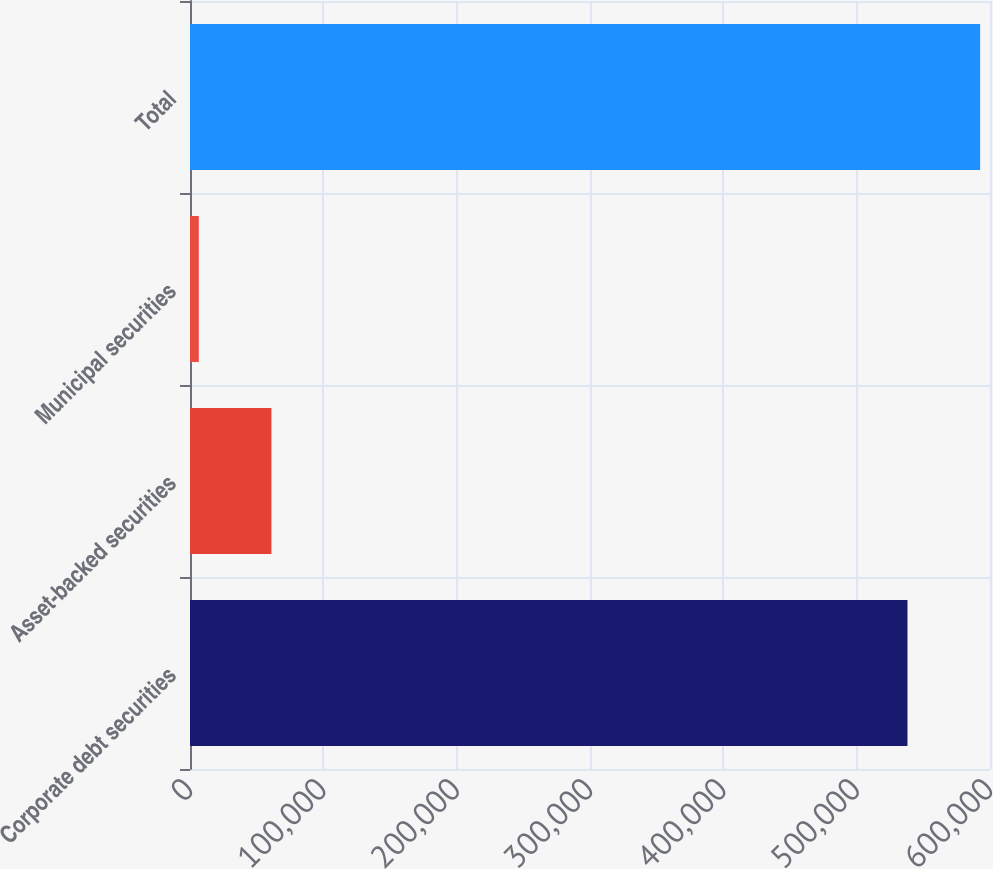Convert chart to OTSL. <chart><loc_0><loc_0><loc_500><loc_500><bar_chart><fcel>Corporate debt securities<fcel>Asset-backed securities<fcel>Municipal securities<fcel>Total<nl><fcel>538109<fcel>61079.5<fcel>6599<fcel>592590<nl></chart> 